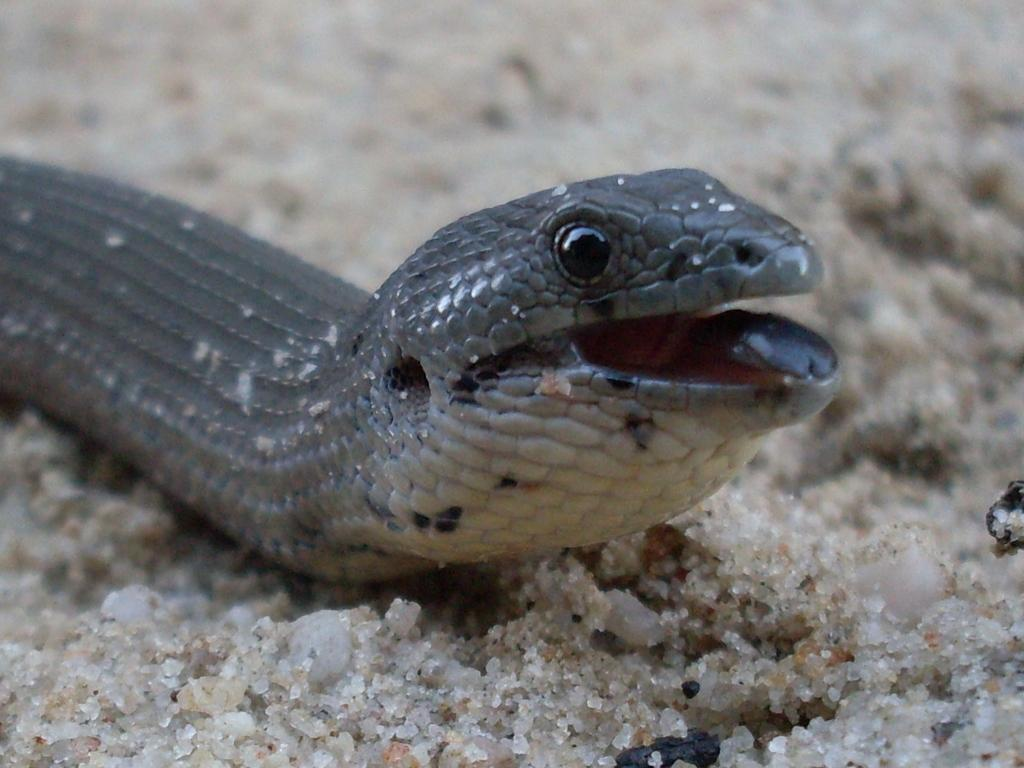What type of animal is in the image? There is a snake in the image. What is the snake resting on in the image? There is sand under the snake. What type of nut is being used by the government in the image? There is no nut or government present in the image; it features a snake resting on sand. 